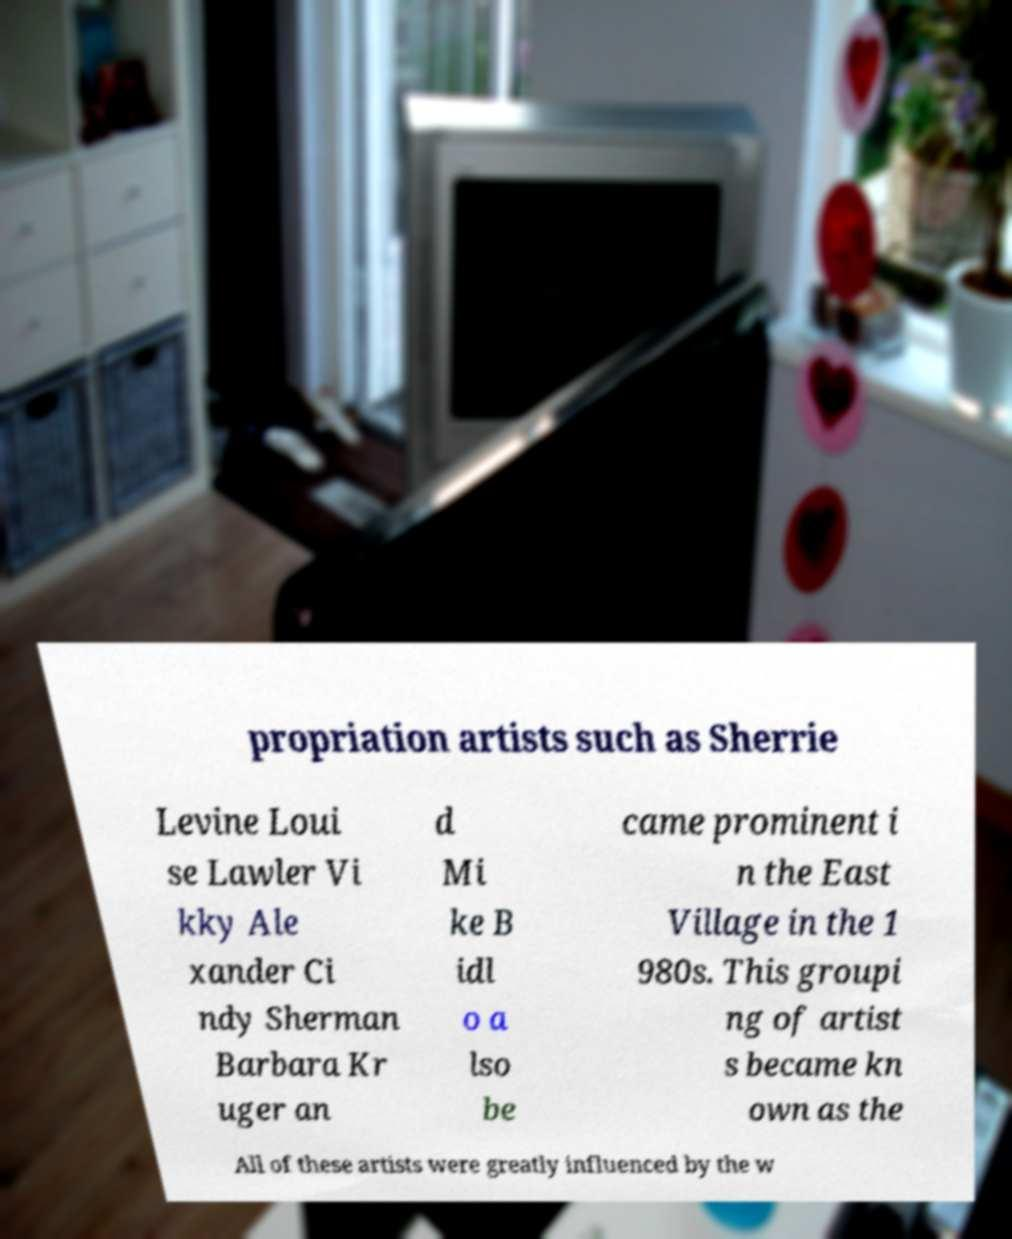There's text embedded in this image that I need extracted. Can you transcribe it verbatim? propriation artists such as Sherrie Levine Loui se Lawler Vi kky Ale xander Ci ndy Sherman Barbara Kr uger an d Mi ke B idl o a lso be came prominent i n the East Village in the 1 980s. This groupi ng of artist s became kn own as the All of these artists were greatly influenced by the w 